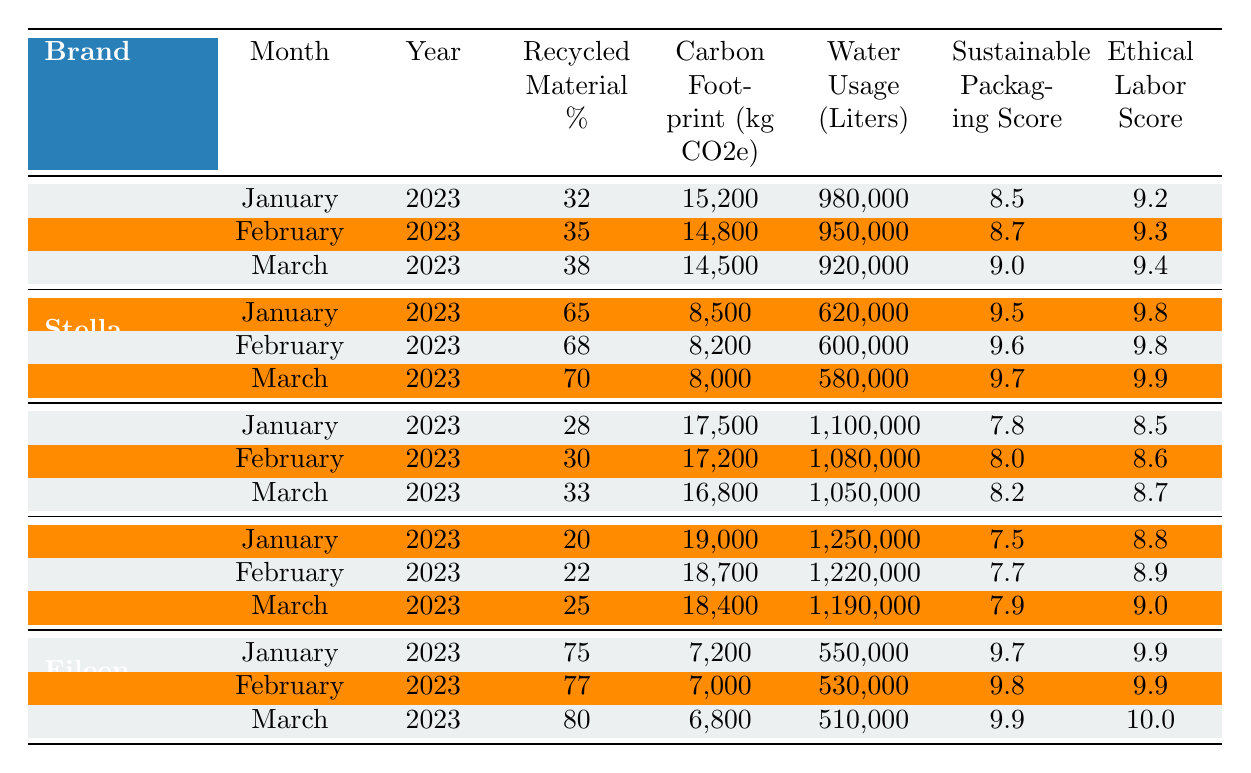What is the highest Recycled Material Percentage among the brands in March 2023? In March 2023, the Recycled Material Percentage values for each brand are: Gucci (38%), Stella McCartney (70%), Burberry (33%), Hermès (25%), and Eileen Fisher (80%). The highest value is from Eileen Fisher at 80%.
Answer: 80% Which brand had the lowest Carbon Footprint in January 2023? In January 2023, the Carbon Footprint values are: Gucci (15,200 kg CO2e), Stella McCartney (8,500 kg CO2e), Burberry (17,500 kg CO2e), Hermès (19,000 kg CO2e), and Eileen Fisher (7,200 kg CO2e). The lowest value is from Eileen Fisher at 7,200 kg CO2e.
Answer: 7,200 kg CO2e What is the average Sustainable Packaging Score for Gucci across the three months? The Sustainable Packaging Scores for Gucci in January, February, and March are 8.5, 8.7, and 9.0. To find the average, sum these scores (8.5 + 8.7 + 9.0 = 26.2) and divide by 3 (26.2 / 3 = 8.73).
Answer: 8.73 Did any brand increase its Water Usage from January to March 2023? Reviewing the Water Usage from January to March for each brand: Gucci increased from 980,000 to 920,000 liters, Stella McCartney decreased from 620,000 to 580,000 liters, Burberry decreased from 1,100,000 to 1,050,000 liters, Hermès decreased from 1,250,000 to 1,190,000 liters, and Eileen Fisher decreased from 550,000 to 510,000 liters. None of the brands increased their Water Usage during this period.
Answer: No Which brand improved its Ethical Labor Score from January to March 2023? Looking at the Ethical Labor Scores, Gucci went from 9.2 to 9.4, Stella McCartney went from 9.8 to 9.9, Burberry went from 8.5 to 8.7, Hermès went from 8.8 to 9.0, and Eileen Fisher went from 9.9 to 10.0. All brands listed improved their scores, indicating a trend of better ethical practices.
Answer: Yes, all improved What is the total Water Usage for all brands in February 2023? The Water Usage values in February 2023 are: Gucci (950,000 liters), Stella McCartney (600,000 liters), Burberry (1,080,000 liters), Hermès (1,220,000 liters), and Eileen Fisher (530,000 liters). The total can be calculated as (950,000 + 600,000 + 1,080,000 + 1,220,000 + 530,000 = 4,380,000 liters).
Answer: 4,380,000 liters 